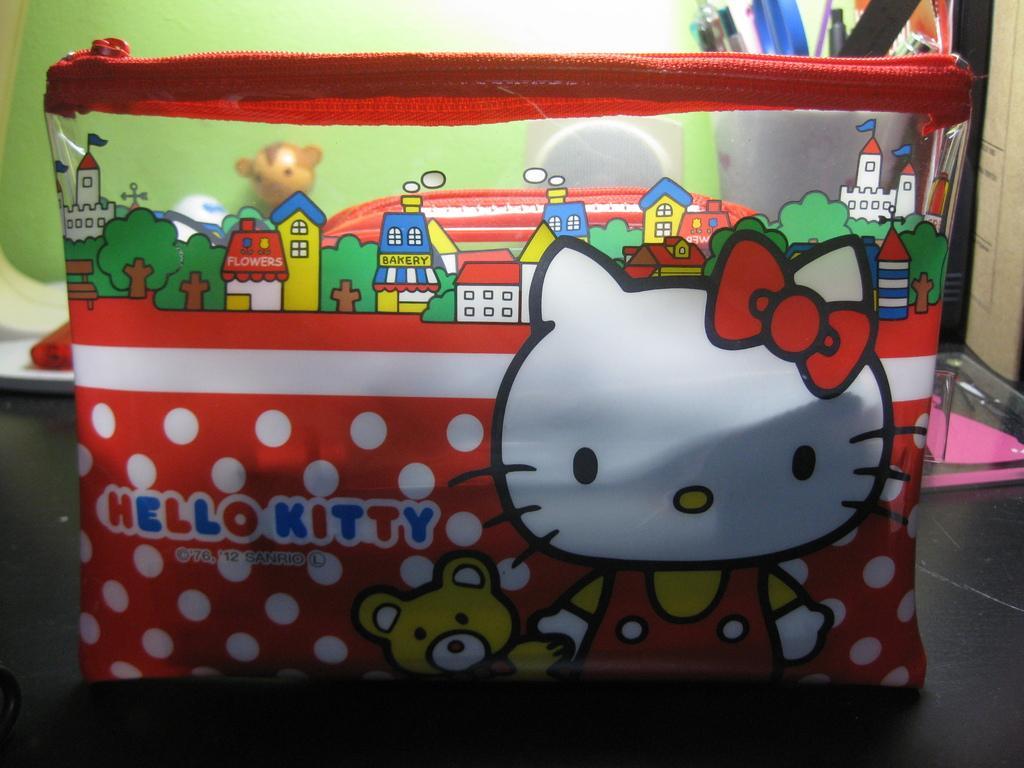How would you summarize this image in a sentence or two? In this image I can see a red colour pouch in the front and on it I can see few cartoon images. I can also see something is written on the pouch. In the background I can see a white colour thing and in it I can see number of pens. I can also see few toys like things in the background. On the right side of the image I can see a black and pink colour thing. 